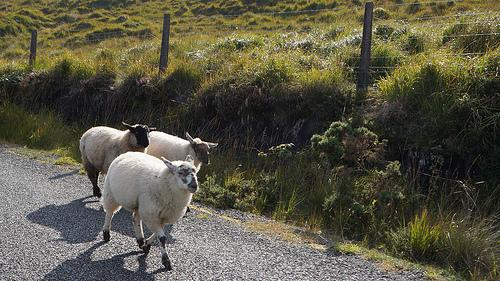Question: where was the picture taken?
Choices:
A. In the city.
B. By the barn.
C. In the corn field.
D. At a farm.
Answer with the letter. Answer: D Question: where are the sheep?
Choices:
A. In the pasture.
B. In the barn.
C. On the road.
D. In my car.
Answer with the letter. Answer: C Question: what color are the sheep?
Choices:
A. Yellow.
B. White and black.
C. Brown.
D. Gray.
Answer with the letter. Answer: B Question: what are the sheep on?
Choices:
A. Hay.
B. The road.
C. Grass.
D. Your car.
Answer with the letter. Answer: B Question: how many sheep are there?
Choices:
A. Three.
B. Two.
C. Four.
D. One.
Answer with the letter. Answer: A 